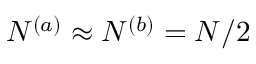<formula> <loc_0><loc_0><loc_500><loc_500>N ^ { ( a ) } \approx N ^ { ( b ) } = N / 2</formula> 